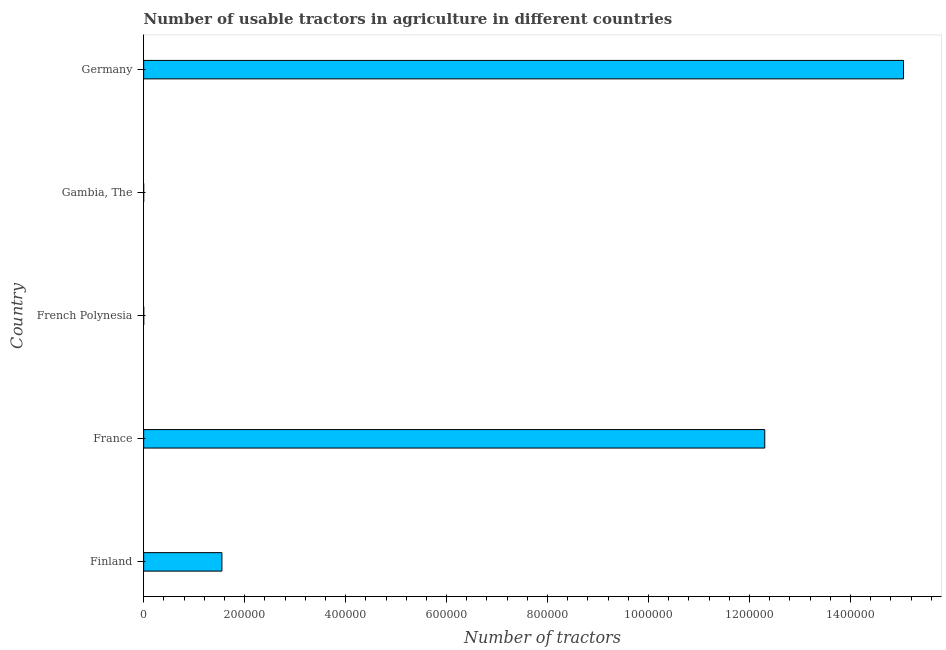Does the graph contain grids?
Ensure brevity in your answer.  No. What is the title of the graph?
Offer a terse response. Number of usable tractors in agriculture in different countries. What is the label or title of the X-axis?
Your answer should be very brief. Number of tractors. What is the number of tractors in French Polynesia?
Provide a succinct answer. 130. Across all countries, what is the maximum number of tractors?
Ensure brevity in your answer.  1.50e+06. Across all countries, what is the minimum number of tractors?
Ensure brevity in your answer.  45. In which country was the number of tractors maximum?
Make the answer very short. Germany. In which country was the number of tractors minimum?
Your response must be concise. Gambia, The. What is the sum of the number of tractors?
Make the answer very short. 2.89e+06. What is the difference between the number of tractors in Finland and France?
Make the answer very short. -1.08e+06. What is the average number of tractors per country?
Provide a succinct answer. 5.78e+05. What is the median number of tractors?
Your answer should be very brief. 1.55e+05. In how many countries, is the number of tractors greater than 1480000 ?
Make the answer very short. 1. What is the ratio of the number of tractors in France to that in French Polynesia?
Give a very brief answer. 9463.08. What is the difference between the highest and the second highest number of tractors?
Keep it short and to the point. 2.75e+05. What is the difference between the highest and the lowest number of tractors?
Make the answer very short. 1.50e+06. How many bars are there?
Give a very brief answer. 5. Are all the bars in the graph horizontal?
Your answer should be very brief. Yes. How many countries are there in the graph?
Your answer should be compact. 5. Are the values on the major ticks of X-axis written in scientific E-notation?
Give a very brief answer. No. What is the Number of tractors of Finland?
Provide a short and direct response. 1.55e+05. What is the Number of tractors of France?
Provide a succinct answer. 1.23e+06. What is the Number of tractors in French Polynesia?
Your response must be concise. 130. What is the Number of tractors of Gambia, The?
Offer a terse response. 45. What is the Number of tractors of Germany?
Offer a terse response. 1.50e+06. What is the difference between the Number of tractors in Finland and France?
Your response must be concise. -1.08e+06. What is the difference between the Number of tractors in Finland and French Polynesia?
Give a very brief answer. 1.55e+05. What is the difference between the Number of tractors in Finland and Gambia, The?
Keep it short and to the point. 1.55e+05. What is the difference between the Number of tractors in Finland and Germany?
Give a very brief answer. -1.35e+06. What is the difference between the Number of tractors in France and French Polynesia?
Your answer should be very brief. 1.23e+06. What is the difference between the Number of tractors in France and Gambia, The?
Make the answer very short. 1.23e+06. What is the difference between the Number of tractors in France and Germany?
Give a very brief answer. -2.75e+05. What is the difference between the Number of tractors in French Polynesia and Germany?
Keep it short and to the point. -1.50e+06. What is the difference between the Number of tractors in Gambia, The and Germany?
Make the answer very short. -1.50e+06. What is the ratio of the Number of tractors in Finland to that in France?
Your answer should be compact. 0.13. What is the ratio of the Number of tractors in Finland to that in French Polynesia?
Offer a terse response. 1192.31. What is the ratio of the Number of tractors in Finland to that in Gambia, The?
Offer a terse response. 3444.44. What is the ratio of the Number of tractors in Finland to that in Germany?
Offer a terse response. 0.1. What is the ratio of the Number of tractors in France to that in French Polynesia?
Provide a succinct answer. 9463.08. What is the ratio of the Number of tractors in France to that in Gambia, The?
Your answer should be very brief. 2.73e+04. What is the ratio of the Number of tractors in France to that in Germany?
Ensure brevity in your answer.  0.82. What is the ratio of the Number of tractors in French Polynesia to that in Gambia, The?
Offer a terse response. 2.89. What is the ratio of the Number of tractors in Gambia, The to that in Germany?
Provide a succinct answer. 0. 